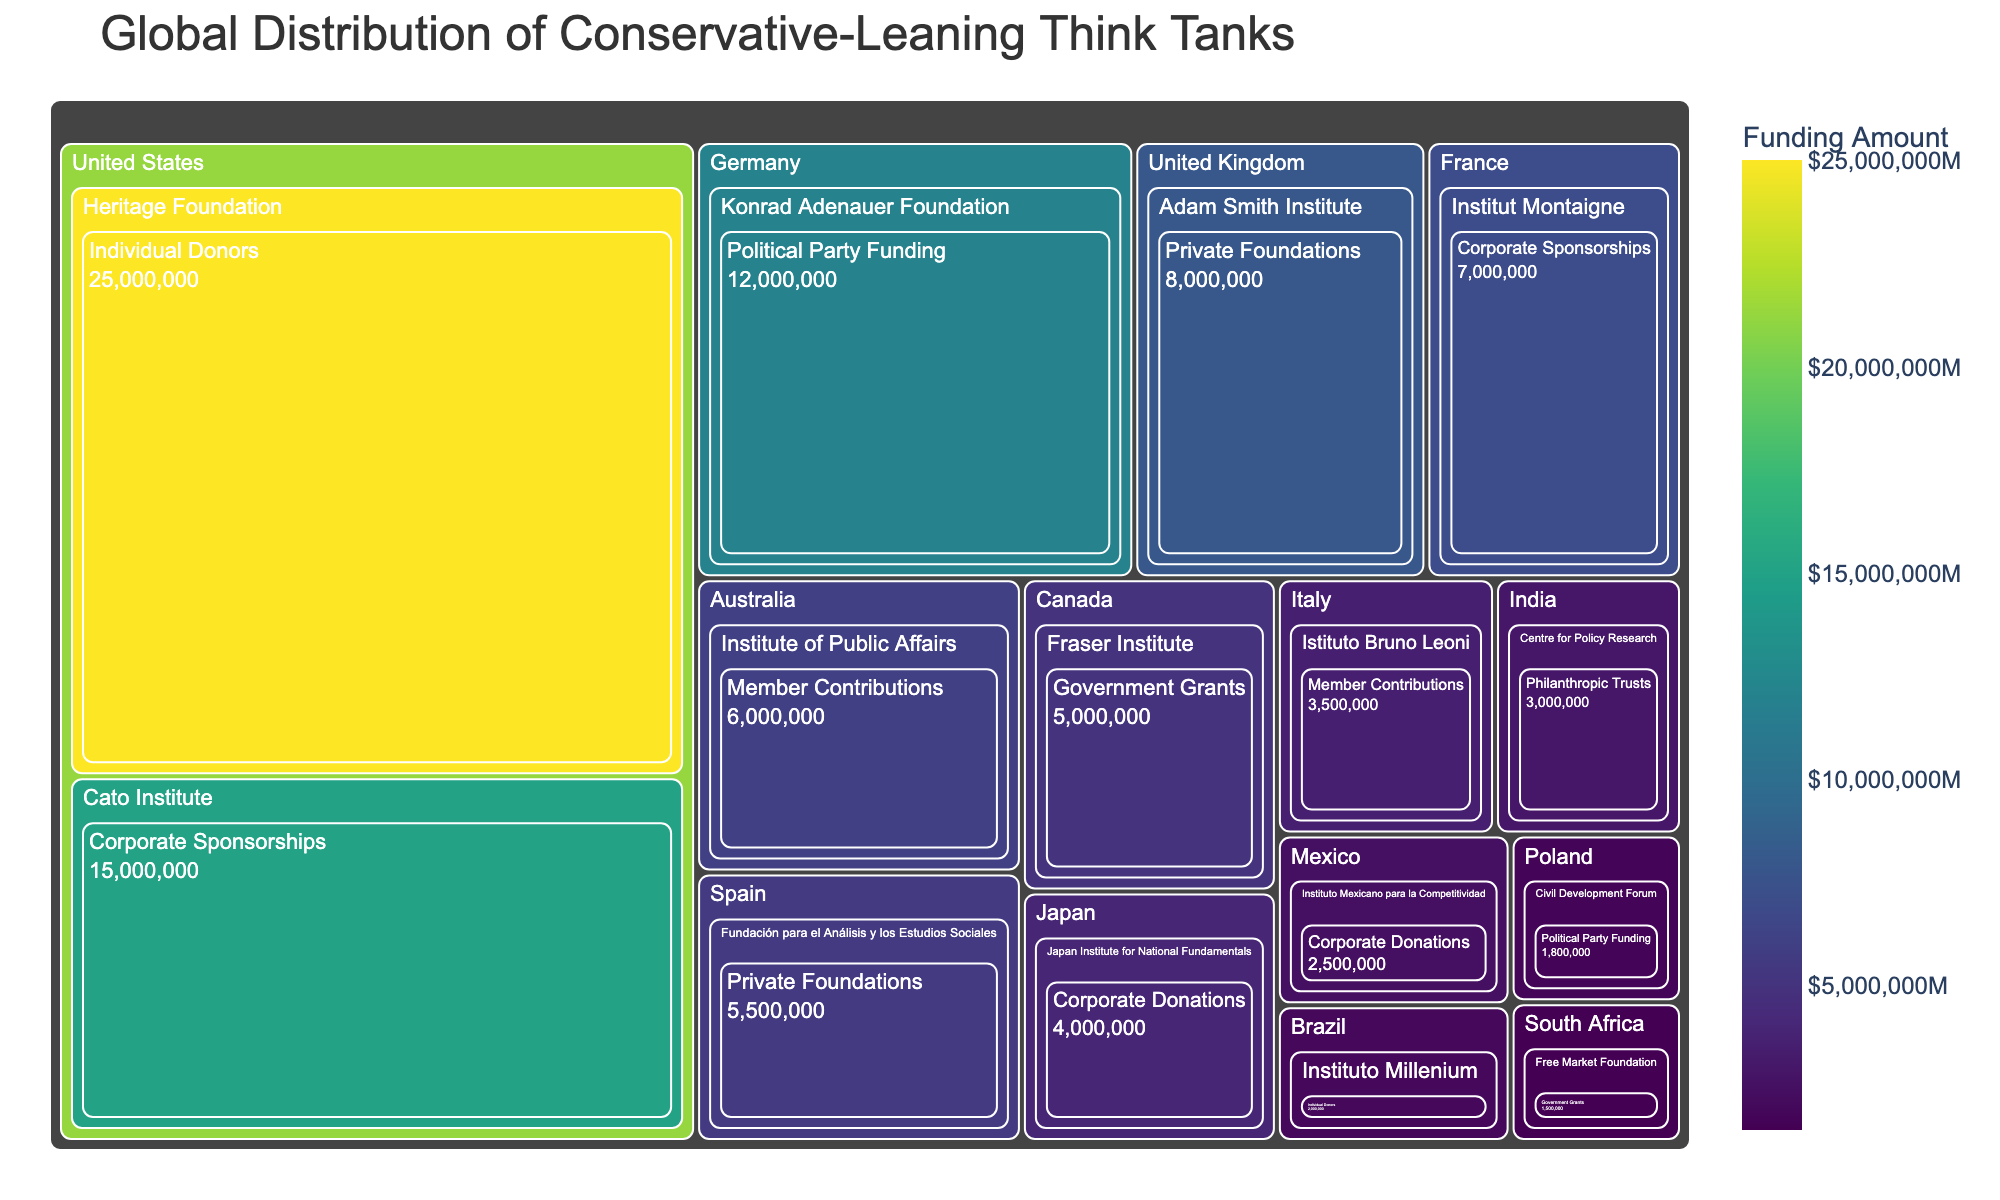What's the total funding amount for conservative-leaning think tanks in the United States? Add the funding amounts of the Heritage Foundation ($25M) and Cato Institute ($15M) to find the total funding amount.
Answer: $40M Which think tank in Europe has the highest funding amount? Compare the funding amounts of the think tanks in the United Kingdom, Germany, France, Spain, and Italy. The Konrad Adenauer Foundation in Germany has the highest funding with $12M.
Answer: Konrad Adenauer Foundation How does the funding of individual donors in the United States compare to corporate sponsorships in the United States? The Heritage Foundation receives $25M from individual donors and the Cato Institute receives $15M from corporate sponsorships. Compare $25M and $15M.
Answer: Individual donors receive more funding Which country has the most diverse sources of funding for its think tanks? Observe which country's think tanks have the most varied funding sources. The United States has think tanks funded by individual donors and corporate sponsorships.
Answer: United States Count the number of countries represented in the treemap. Count each unique country listed which includes the United States, United Kingdom, Australia, Canada, Germany, Japan, India, Brazil, France, Spain, Italy, South Africa, Mexico, and Poland.
Answer: 14 What's the total funding amount from government grants across all countries? Sum the funding amounts from government grants for the Fraser Institute in Canada ($5M) and the Free Market Foundation in South Africa ($1.5M).
Answer: $6.5M How does the funding of the Konrad Adenauer Foundation compare to the total funding of think tanks in Japan and India combined? The Konrad Adenauer Foundation has $12M. The Japan Institute for National Fundamentals has $4M and the Centre for Policy Research has $3M. The total for Japan and India is $7M. Compare $12M and $7M.
Answer: The Konrad Adenauer Foundation has more funding Which country's think tanks are entirely funded by corporate donations or sponsorships? Identify countries whose think tanks have corporate donations or sponsorships as their only funding sources. Mexico ($2.5M corporate donations) and France ($7M corporate sponsorships) fit this criterion.
Answer: Mexico and France What is the average funding amount for think tanks in Europe? Add the funding amounts for think tanks in the United Kingdom ($8M), Germany ($12M), France ($7M), Spain ($5.5M), and Italy ($3.5M), then divide by the number of think tanks (5). ($8M + $12M + $7M + $5.5M + $3.5M) / 5 = $36M / 5 = $7.2M.
Answer: $7.2M Identify the smallest think tank funding amount within the provided data. Review the data and find the smallest funding amount, which is $1.5M for the Free Market Foundation in South Africa.
Answer: $1.5M 